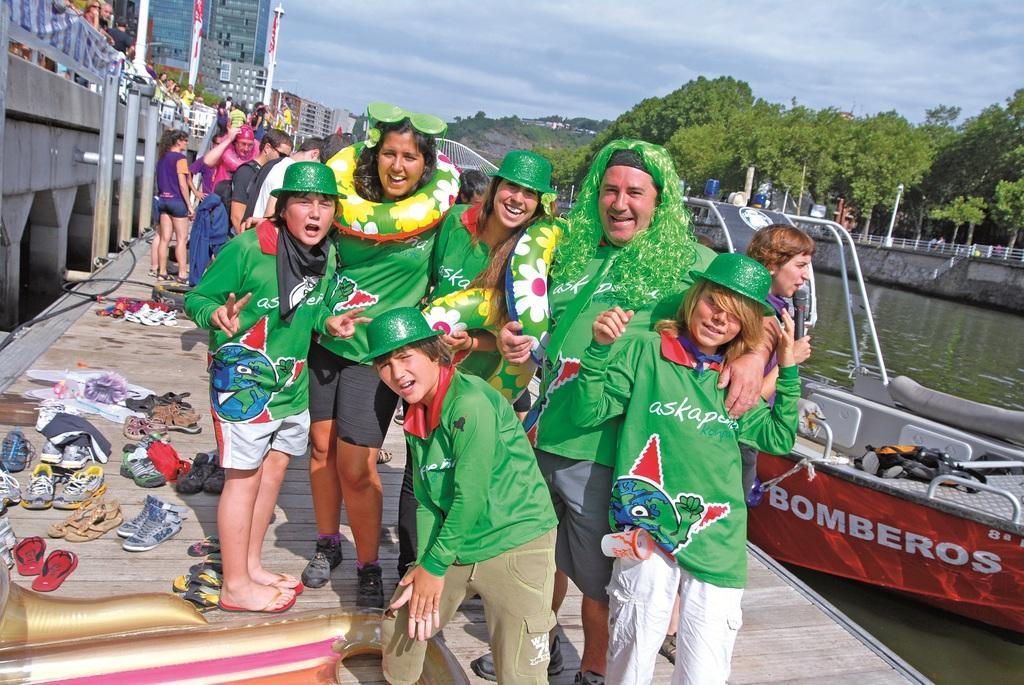Describe this image in one or two sentences. In this picture we can see group of people and a boat on the water, on the left side of the image we can see footwear, on the right side of the image we can find a person is holding a microphone, in the background we can see few buildings, poles, trees and clouds. 